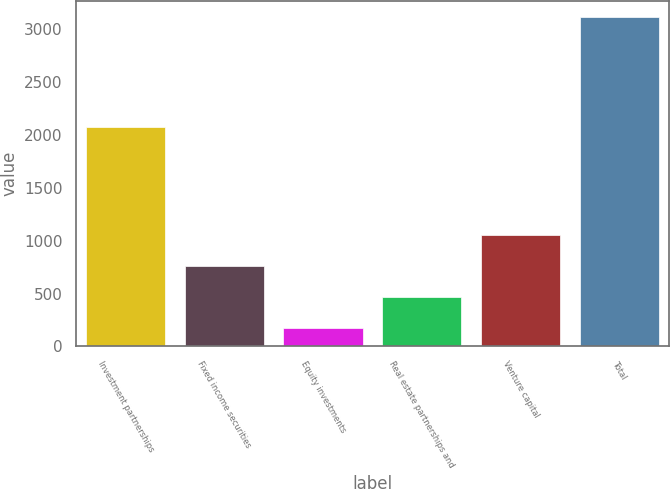<chart> <loc_0><loc_0><loc_500><loc_500><bar_chart><fcel>Investment partnerships<fcel>Fixed income securities<fcel>Equity investments<fcel>Real estate partnerships and<fcel>Venture capital<fcel>Total<nl><fcel>2077<fcel>763.6<fcel>176<fcel>469.8<fcel>1057.4<fcel>3114<nl></chart> 